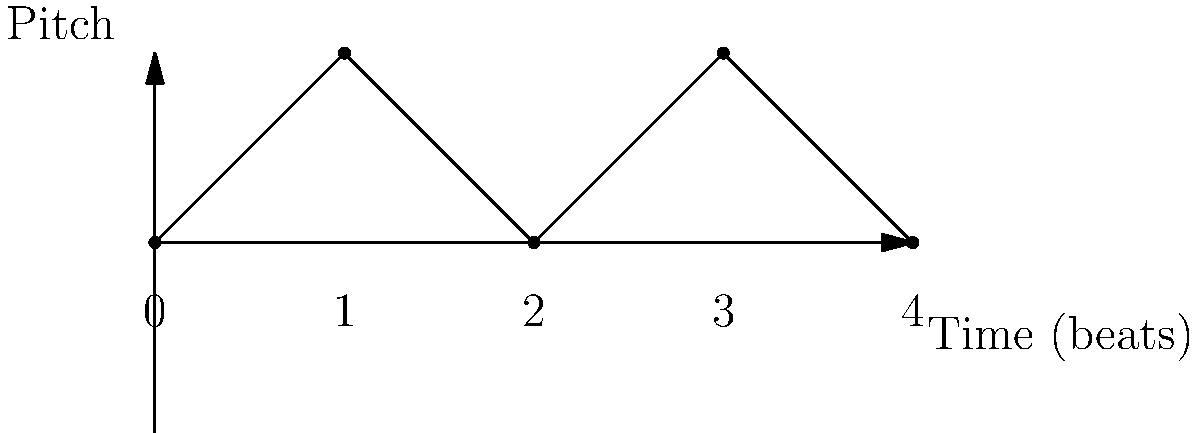Analyze the musical staff representation above, which depicts a common ska punk rhythm pattern. What is the predominant tempo typically associated with this rhythmic structure, and how does it contribute to the genre's characteristic sound? To answer this question, let's break down the analysis step-by-step:

1. Observe the rhythm pattern:
   The graph shows a repeating pattern of alternating high and low notes over 4 beats.

2. Identify the ska punk characteristics:
   - The alternating pattern represents the "skank" rhythm, a defining feature of ska punk.
   - This rhythm emphasizes the offbeats (beats 2 and 4 in a 4/4 time signature).

3. Understand tempo in ska punk:
   - Ska punk typically has a fast tempo, ranging from 150 to 190 beats per minute (BPM).
   - This fast tempo is crucial for creating the energetic, danceable feel of ska punk.

4. Analyze the relationship between rhythm and tempo:
   - The quick alternation between high and low notes (upstrokes and downstrokes on guitar) is accentuated by the fast tempo.
   - This combination creates the distinctive "galloping" feel of ska punk.

5. Consider the effect on the genre's sound:
   - The fast tempo and emphasized offbeats create a driving, upbeat rhythm.
   - This rhythmic structure encourages audience participation (e.g., skanking dance).
   - It also allows for seamless integration of punk rock's intensity with ska's syncopation.

6. Conclude on the predominant tempo:
   The typical tempo for this rhythm in ska punk would be around 170 BPM, fast enough to create energy but not so fast as to lose the ska feel.
Answer: Approximately 170 BPM, creating an energetic, syncopated rhythm emphasizing offbeats. 